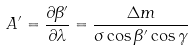<formula> <loc_0><loc_0><loc_500><loc_500>A ^ { \prime } = \frac { \partial \beta ^ { \prime } } { \partial \lambda } = \frac { \Delta m } { \sigma \cos \beta ^ { \prime } \cos \gamma }</formula> 